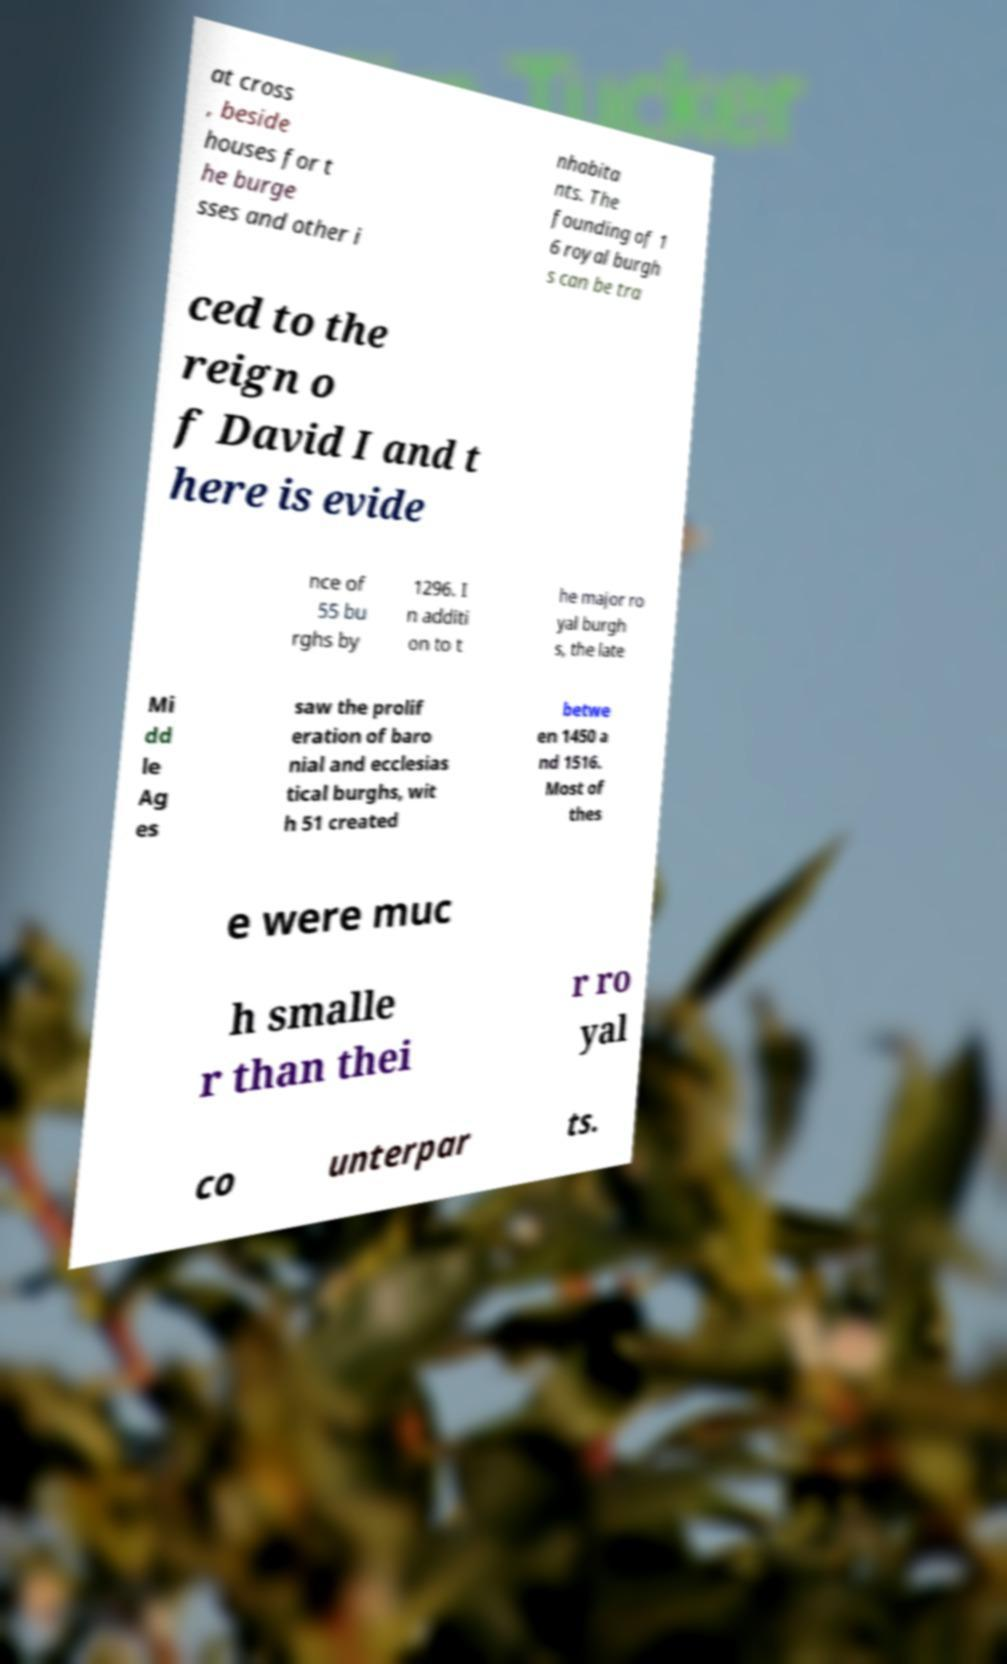I need the written content from this picture converted into text. Can you do that? at cross , beside houses for t he burge sses and other i nhabita nts. The founding of 1 6 royal burgh s can be tra ced to the reign o f David I and t here is evide nce of 55 bu rghs by 1296. I n additi on to t he major ro yal burgh s, the late Mi dd le Ag es saw the prolif eration of baro nial and ecclesias tical burghs, wit h 51 created betwe en 1450 a nd 1516. Most of thes e were muc h smalle r than thei r ro yal co unterpar ts. 